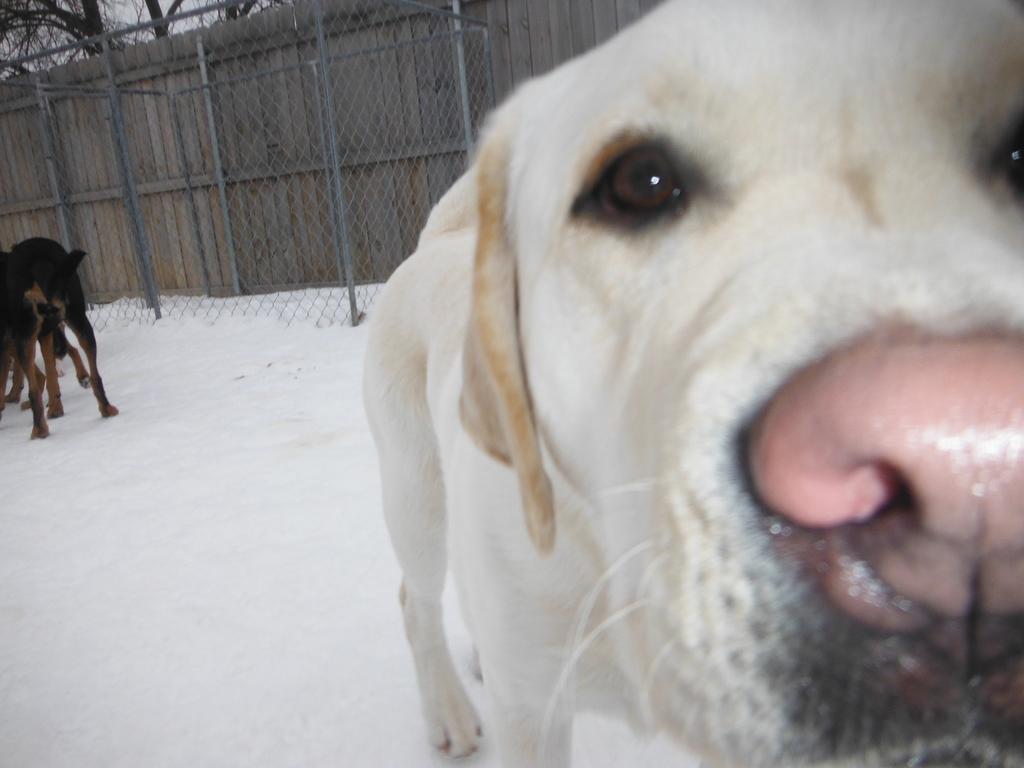Can you describe this image briefly? In this image on the right there is a white dog. Here there are few other dogs. In the background there is boundary, trees. On the ground there is snow. 